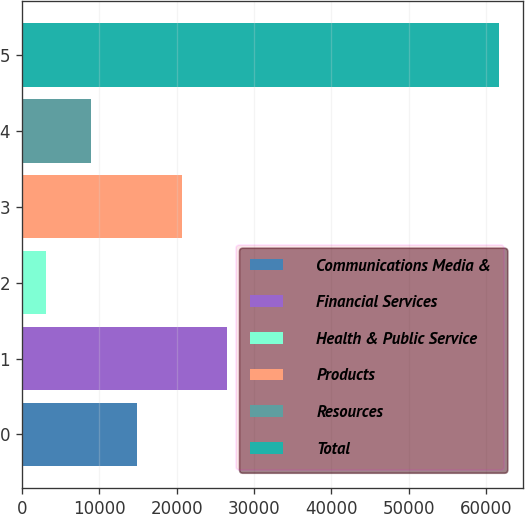Convert chart. <chart><loc_0><loc_0><loc_500><loc_500><bar_chart><fcel>Communications Media &<fcel>Financial Services<fcel>Health & Public Service<fcel>Products<fcel>Resources<fcel>Total<nl><fcel>14840.2<fcel>26538.4<fcel>3142<fcel>20689.3<fcel>8991.1<fcel>61633<nl></chart> 